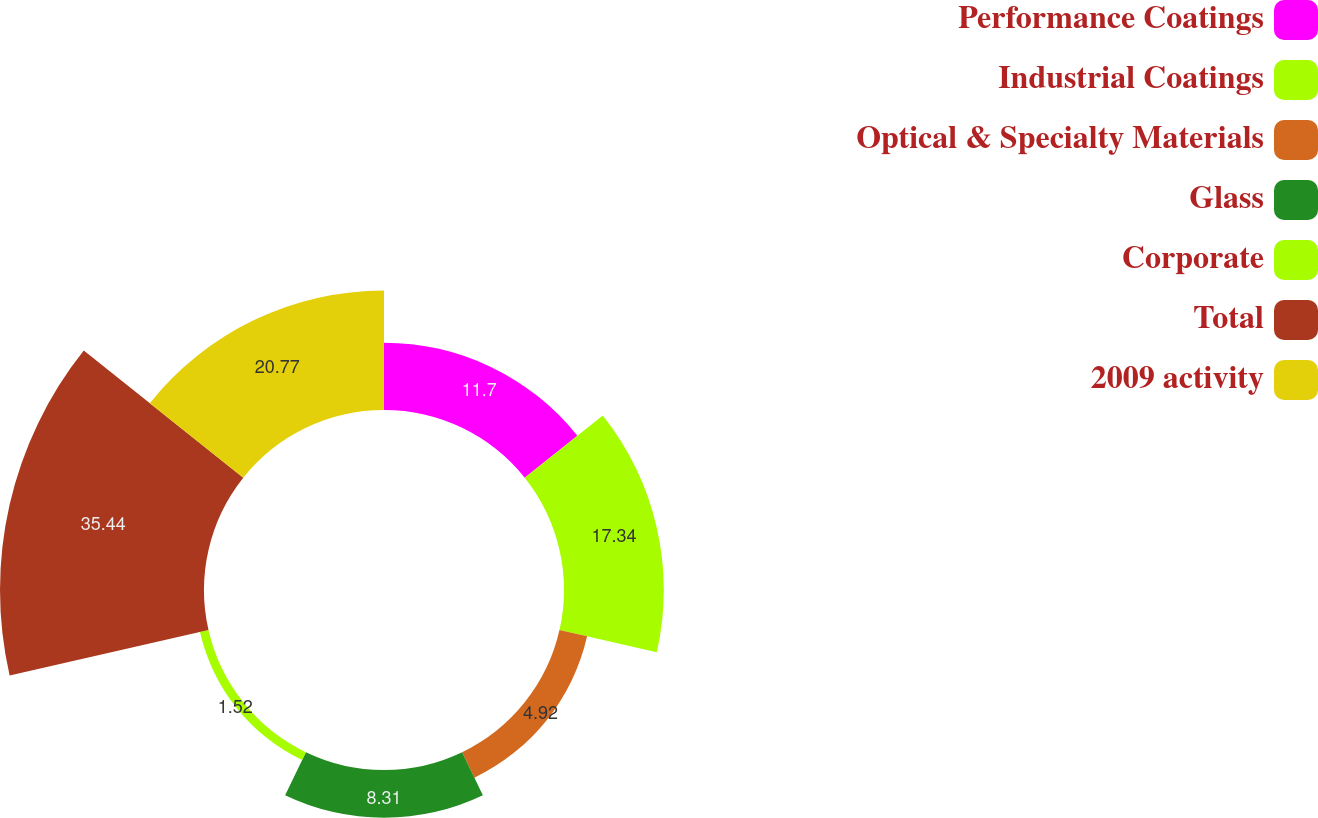Convert chart to OTSL. <chart><loc_0><loc_0><loc_500><loc_500><pie_chart><fcel>Performance Coatings<fcel>Industrial Coatings<fcel>Optical & Specialty Materials<fcel>Glass<fcel>Corporate<fcel>Total<fcel>2009 activity<nl><fcel>11.7%<fcel>17.34%<fcel>4.92%<fcel>8.31%<fcel>1.52%<fcel>35.44%<fcel>20.77%<nl></chart> 